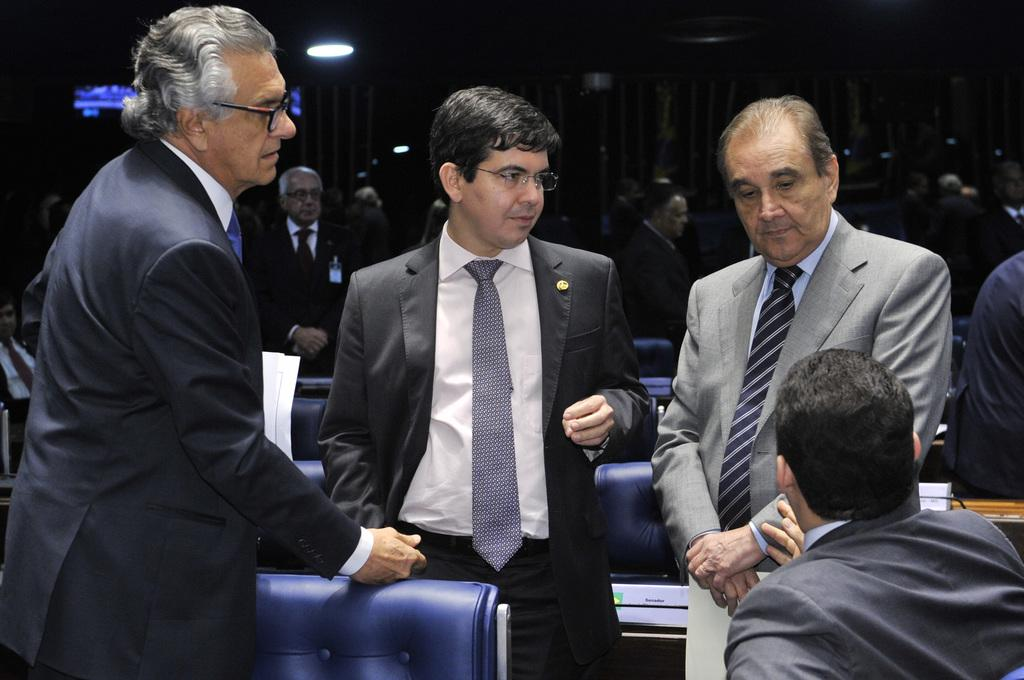What are the people in the image doing? There are people standing in the image, and a man is sitting. What furniture is present in the image? Chairs are visible in the image. Can you describe the people in the background of the image? There are people in the background of the image, but their actions are not clear. How would you describe the lighting in the image? The background is dark, but lights are visible at the top of the image. What type of clam is being used as a hat by one of the people in the image? There is no clam present in the image, let alone being used as a hat. Can you describe the nose of the person sitting in the image? The image does not provide a clear view of the person's nose, so it cannot be described. 